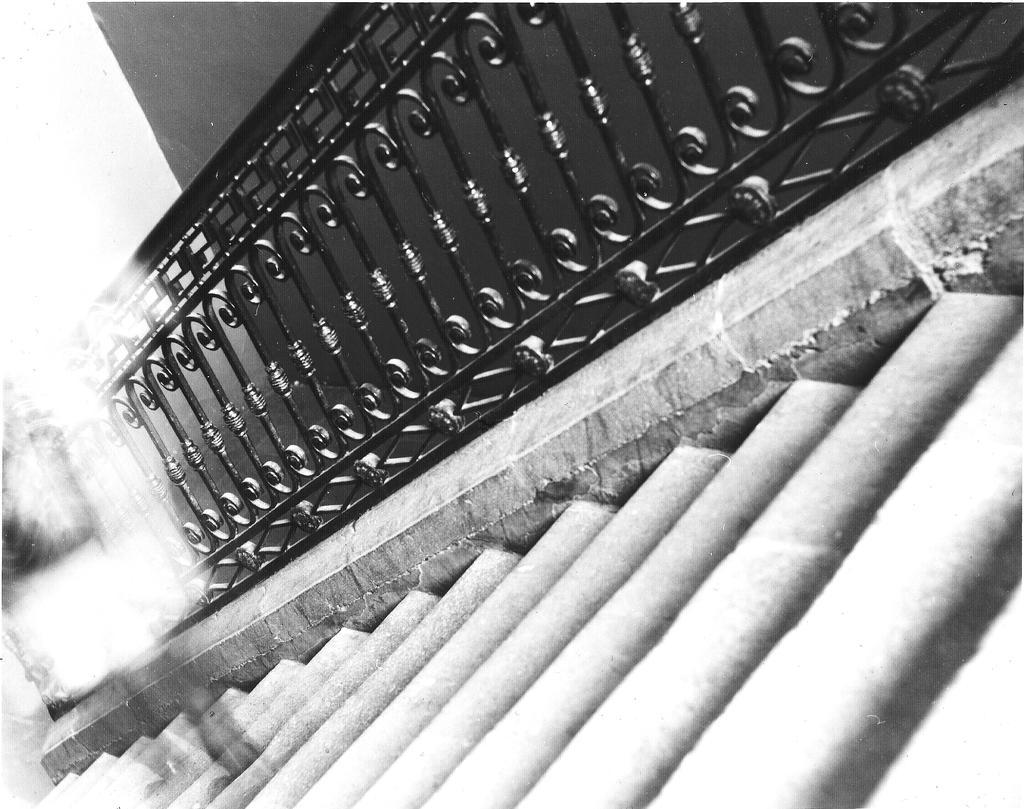In one or two sentences, can you explain what this image depicts? This image is a black and white image. This image is taken indoors. In the middle of the image there is a staircase with a few stairs and a railing. In the background there is a wall. 